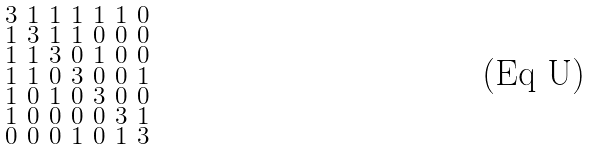Convert formula to latex. <formula><loc_0><loc_0><loc_500><loc_500>\begin{smallmatrix} 3 & 1 & 1 & 1 & 1 & 1 & 0 \\ 1 & 3 & 1 & 1 & 0 & 0 & 0 \\ 1 & 1 & 3 & 0 & 1 & 0 & 0 \\ 1 & 1 & 0 & 3 & 0 & 0 & 1 \\ 1 & 0 & 1 & 0 & 3 & 0 & 0 \\ 1 & 0 & 0 & 0 & 0 & 3 & 1 \\ 0 & 0 & 0 & 1 & 0 & 1 & 3 \end{smallmatrix}</formula> 